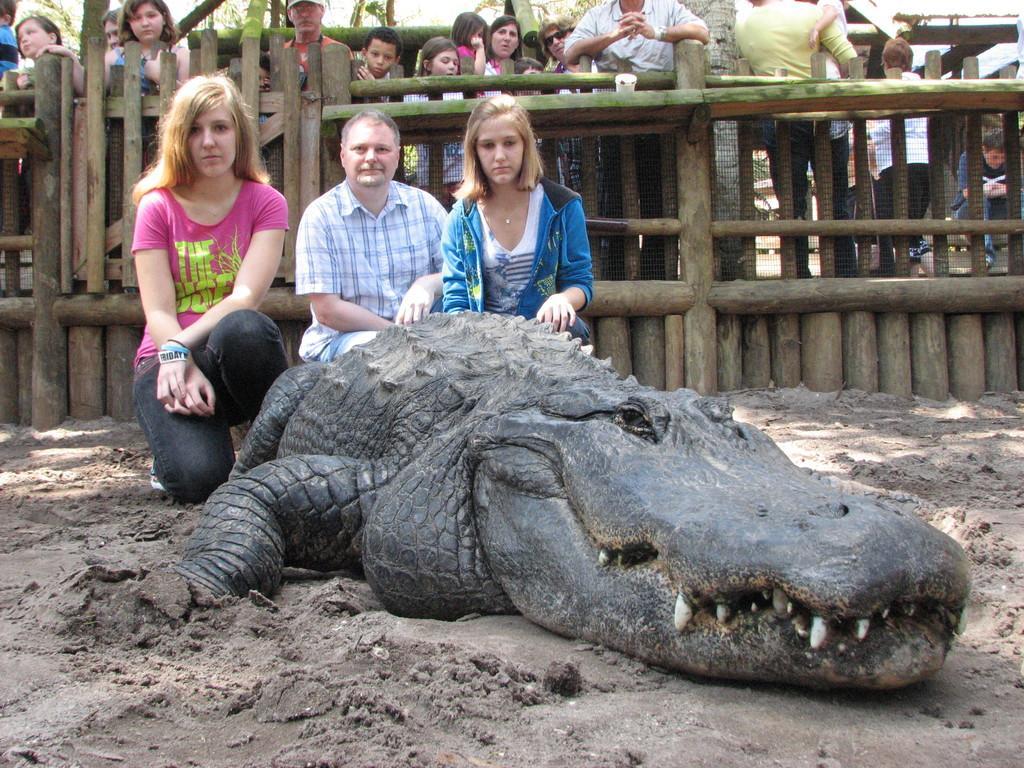Can you describe this image briefly? In this picture we can see there are three persons and an alligator. Behind the three persons, there is a wooden fence and a group of people. 